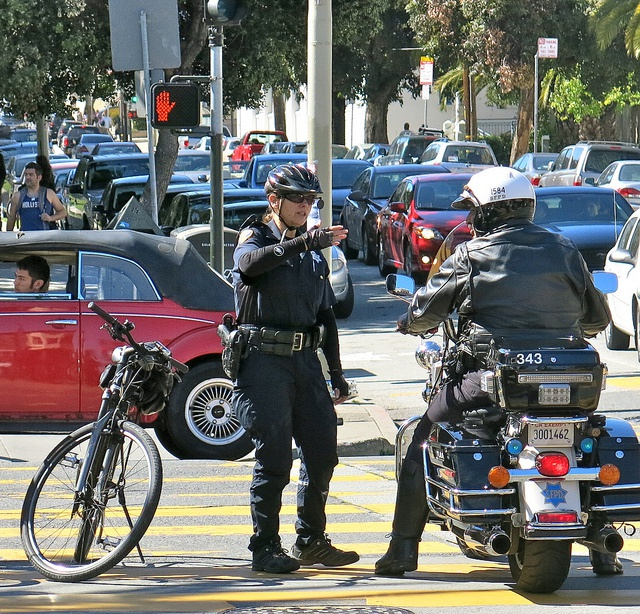Describe the objects in this image and their specific colors. I can see motorcycle in darkgreen, black, gray, darkgray, and navy tones, car in darkgreen, black, and brown tones, people in darkgreen, black, gray, and darkgray tones, people in darkgreen, black, gray, darkblue, and white tones, and car in darkgreen, white, gray, black, and darkgray tones in this image. 